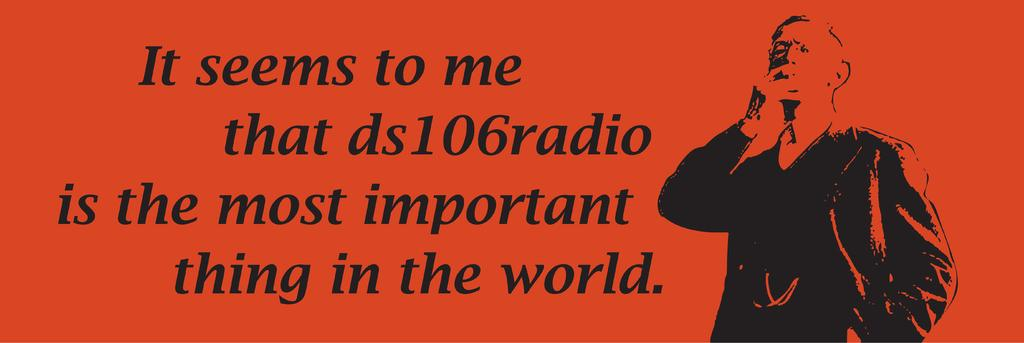What can be found towards the left side of the image? There is some text towards the left side of the image. What is depicted towards the right side of the image? There is a picture of a man towards the right side of the image. Is there a crown visible on the man's head in the image? There is no crown visible on the man's head in the image. Is there a letter being held by the man in the image? There is no letter being held by the man in the image. 